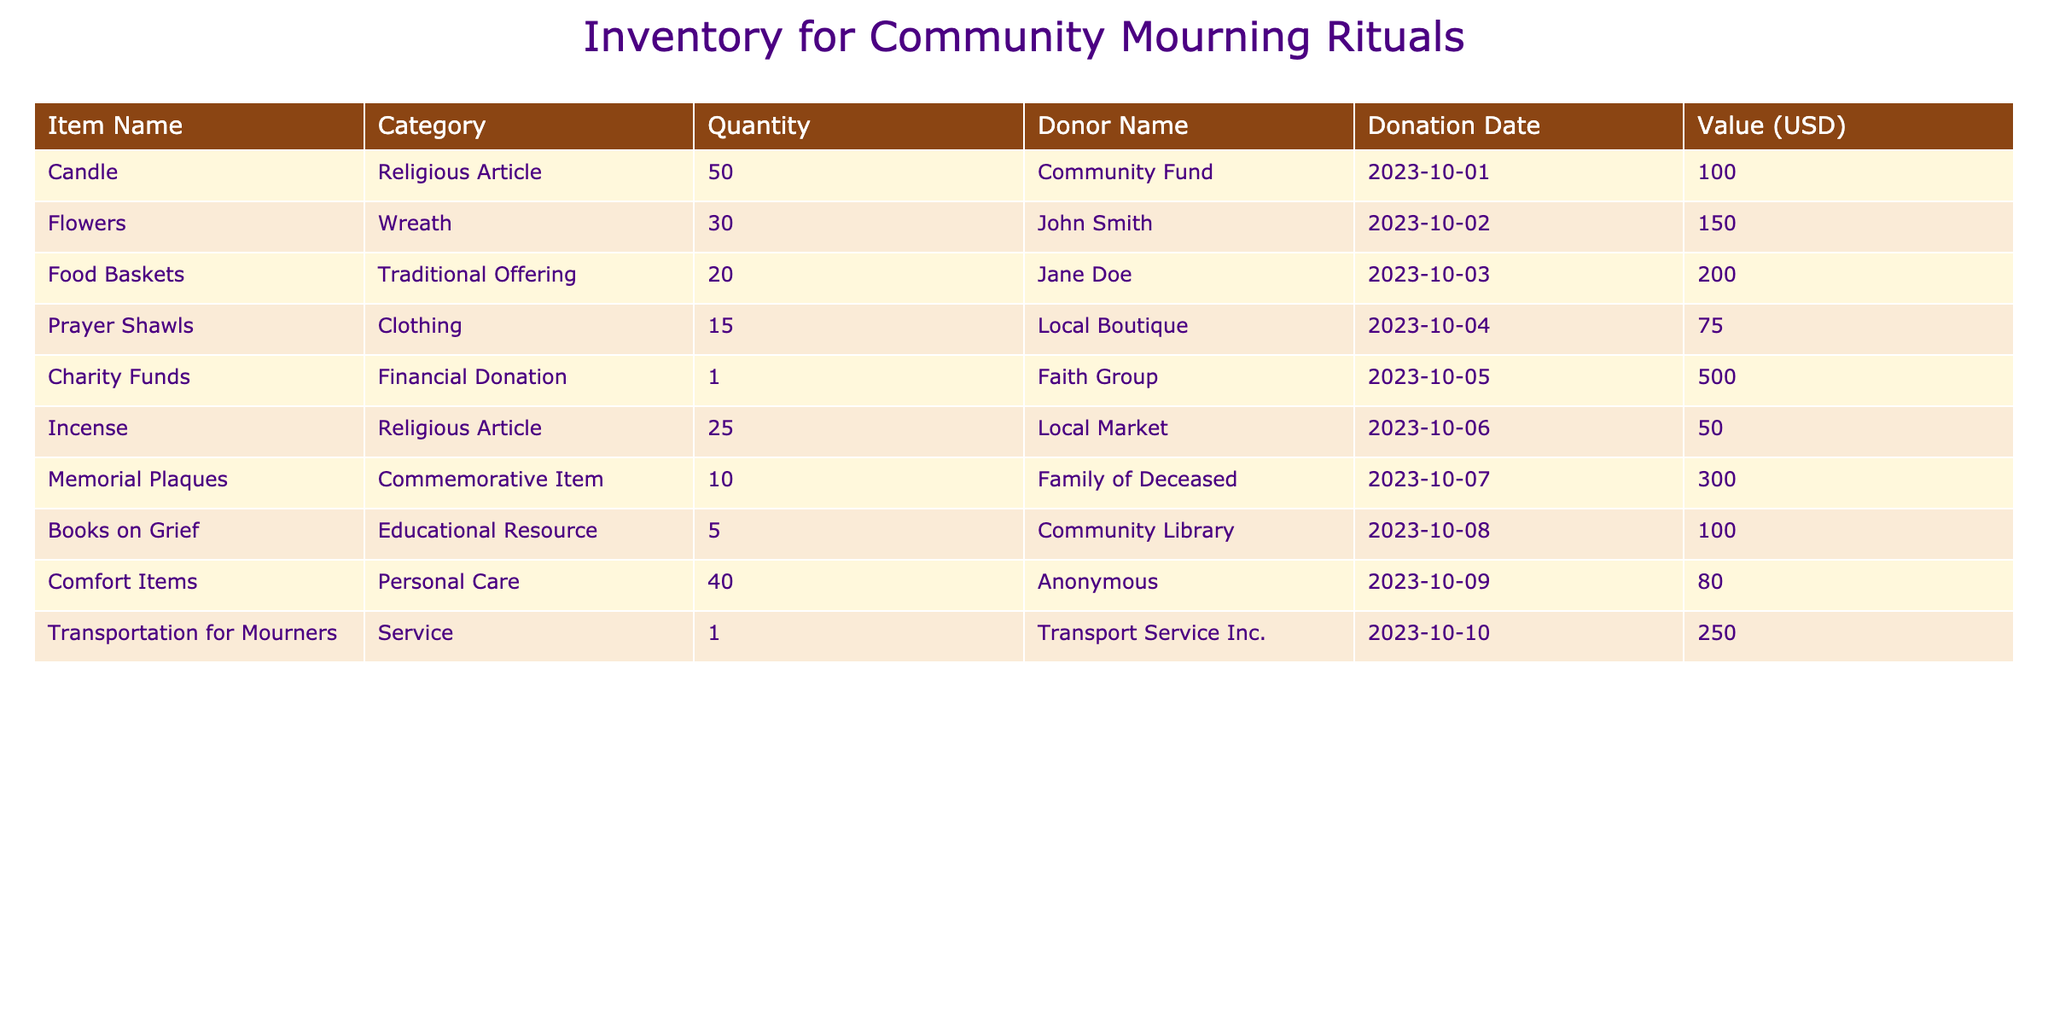What is the total value of donations made by John Smith? To find the total value of donations made by John Smith, we look for rows where the donor name is "John Smith." There is only one entry: Flowers averaging at a value of 150 USD. Therefore, the total value of donations by John Smith is 150 USD.
Answer: 150 USD What is the quantity of food baskets donated for the mourning rituals? The only entry for food baskets in the table specifies a quantity of 20, so we refer to that entry directly.
Answer: 20 Is there a transportation service donation made by a service provider? In the table, there is indeed a transportation entry listed under "Transportation for Mourners" with donor name "Transport Service Inc." This confirms that a transportation service donation exists.
Answer: Yes Which item has the highest quantity donated, and what is that quantity? By reviewing the Quantity column, we see that Comfort Items have the highest quantity of 40. We confirm that no other item exceeds this quantity. Therefore, the highest quantity is Comfort Items with 40.
Answer: Comfort Items: 40 What is the total value of all the charitable donations listed in the table? To calculate the total value, we sum up all the values from the Value column: 100 + 150 + 200 + 75 + 500 + 50 + 300 + 100 + 80 + 250 = 1,705 USD.
Answer: 1,705 USD What percentage of the total donations does the value of charity funds represent? First, we see the value of Charity Funds is 500 USD. The total donations amount to 1,705 USD (calculated previously). To find the percentage: (500/1705) * 100 = ~29.35%. Therefore, charity funds represent approximately 29.35% of total donations.
Answer: ~29.35% How many different categories of items were donated? From the table, we can enumerate the distinct categories: Religious Article, Wreath, Traditional Offering, Clothing, Financial Donation, Personal Care, Commemorative Item, Educational Resource, and Service. We count a total of 9 unique categories.
Answer: 9 Was there a donation made anonymously? The entry for Comfort Items indicates that the donor name is "Anonymous." This confirms that there is indeed an anonymous donation recorded.
Answer: Yes What is the average value of the donations made by community members (excluding financial donations)? First, we need to identify all non-financial donations and their respective values: 100, 150, 200, 75, 50, 300, 100, 80, and 250 (excluding the value of Charity Funds). The sum of these values is 1,105 USD. Next, we count these donations, which total to 9 items. Thus, the average value is 1,105/9 ≈ 122.78 USD.
Answer: ~122.78 USD 